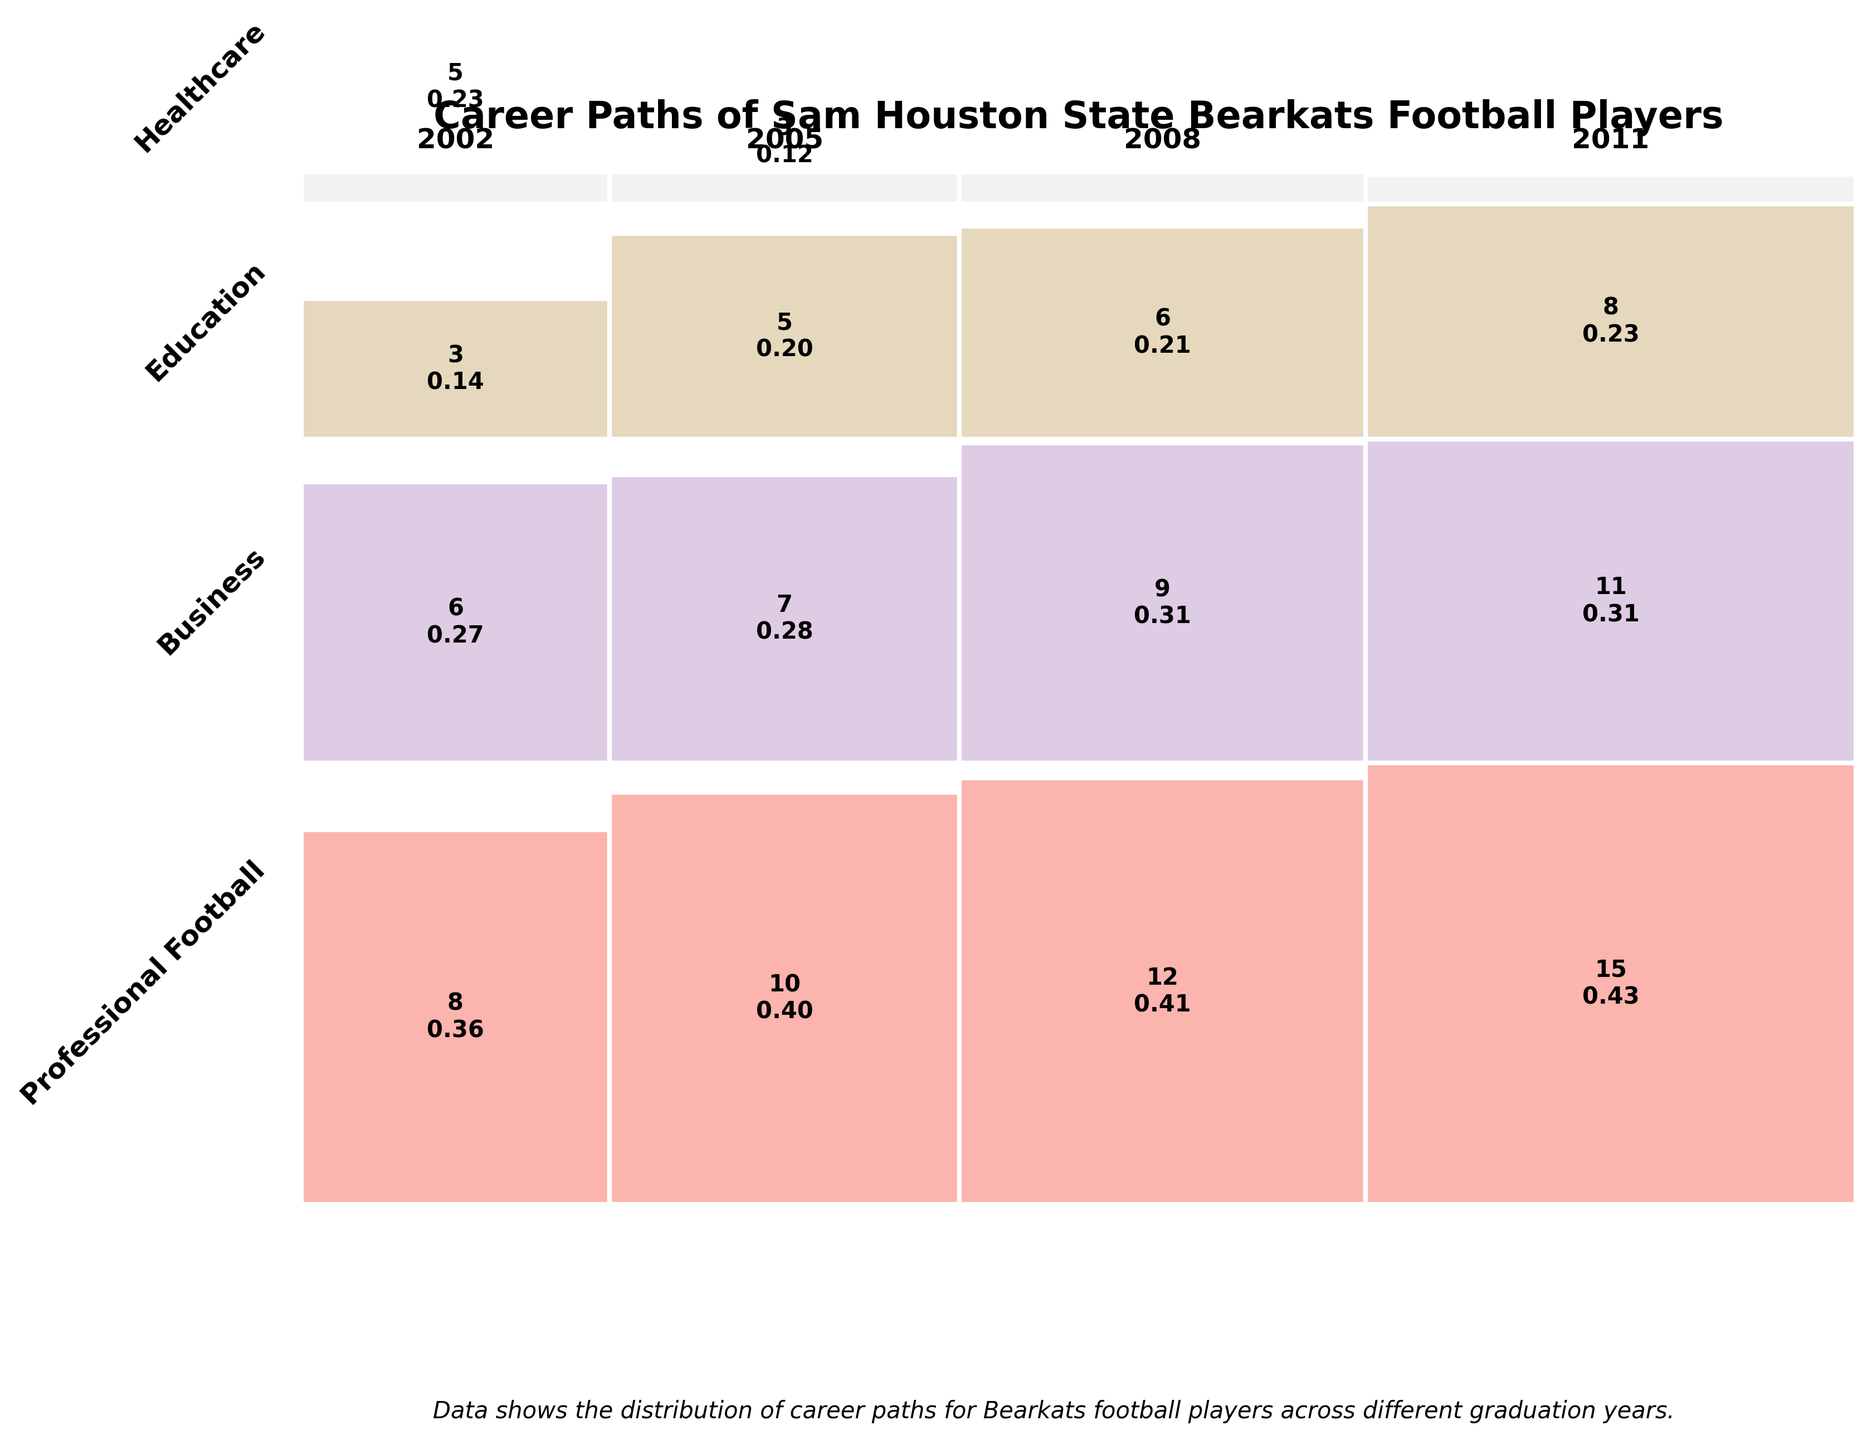What is the title of the figure? The title of the figure is usually found at the top of the chart in larger and bold font. In this instance, the title is "Career Paths of Sam Houston State Bearkats Football Players", as specified in the plotting code provided.
Answer: Career Paths of Sam Houston State Bearkats Football Players How many career paths are represented for Bearkats football players who graduated in 2005? To find this, look at the different sections corresponding to the year 2005. The different colors represent different industries. For the year 2005, the figure shows Professional Football, Business, Education, and Healthcare.
Answer: 4 Which graduation year has the highest number of players entering Business? By observing the widths corresponding to Business across all years, it's evident that the year with the largest section labeled "Business" has the highest count. According to the data, 2011 has 15 players, which is the highest.
Answer: 2011 What is the count and proportion of players in Education who graduated in 2008? Find the section corresponding to Education for 2008 and look for the count and the proportion. The data specifies that the count is 9, and if we look within the figure, we can see the proportional value, which is approximately 0.32.
Answer: 9, 0.32 Compare the proportion of players entering Professional Football between 2002 and 2011. Identify rectangles for Professional Football in 2002 and 2011 and compare their heights. For 2002, 5 out of 22 players entered Professional Football (5/22 ≈ 0.23). For 2011, 1 out of 35 players entered Professional Football (1/35 ≈ 0.03).
Answer: 0.23 (2002), 0.03 (2011) Which industry has the largest variation in the number of graduates over the years? To determine this, observe the range - the difference between the highest and lowest values - for each industry's counts across the years. Business varies from 8 (2002) to 15 (2011). Other industries have less significant variation.
Answer: Business In which year did the highest proportion of players go into Healthcare? Look at which year the tallest segment for Healthcare appears. We can see that the tallest Healthcare segment appears in 2011, with an 8 out of a total of 35.
Answer: 2011 What is the total number of players represented in the year 2008? Sum the counts of all industries for 2008: 2 (Professional Football) + 12 (Business) + 9 (Education) + 6 (Healthcare), which equates to 29.
Answer: 29 Which industry has the smallest proportion of graduates in 2005? Compare the height of rectangles for all industries within the year 2005. The smallest proportion is for Professional Football, with 3 out of 25 graduates, which is 0.12.
Answer: Professional Football 